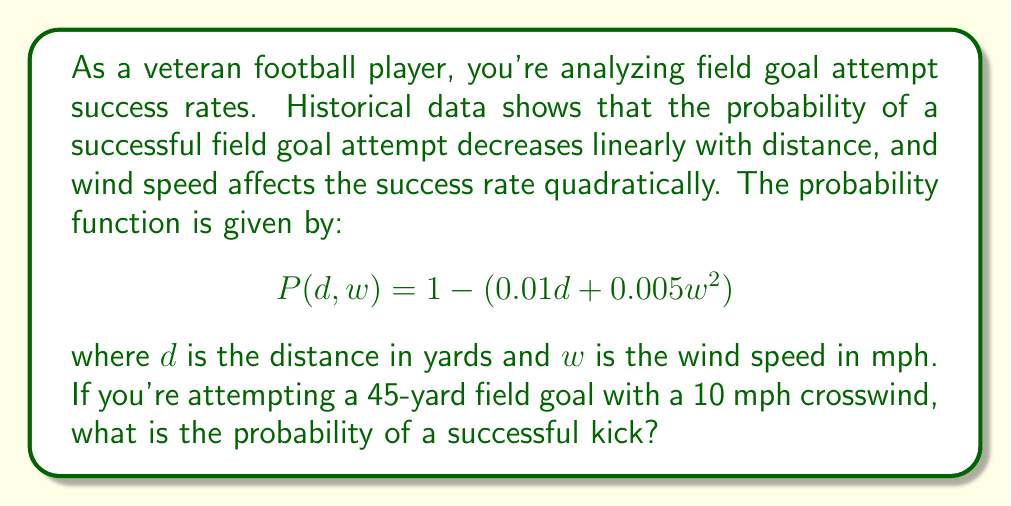Teach me how to tackle this problem. To solve this problem, we need to use the given probability function and substitute the known values:

1) The probability function is:
   $$P(d,w) = 1 - (0.01d + 0.005w^2)$$

2) We're given:
   - Distance (d) = 45 yards
   - Wind speed (w) = 10 mph

3) Let's substitute these values into the equation:
   $$P(45,10) = 1 - (0.01 * 45 + 0.005 * 10^2)$$

4) First, let's calculate the terms inside the parentheses:
   - $0.01 * 45 = 0.45$
   - $0.005 * 10^2 = 0.005 * 100 = 0.5$

5) Now, our equation looks like this:
   $$P(45,10) = 1 - (0.45 + 0.5)$$

6) Add the terms inside the parentheses:
   $$P(45,10) = 1 - 0.95$$

7) Finally, subtract:
   $$P(45,10) = 0.05$$

Therefore, the probability of a successful 45-yard field goal with a 10 mph crosswind is 0.05 or 5%.
Answer: 0.05 or 5% 